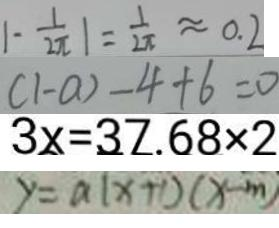<formula> <loc_0><loc_0><loc_500><loc_500>\vert - \frac { 1 } { 2 \pi } \vert = \frac { 1 } { 2 \pi } \approx 0 . 2 
 ( 1 - a ) - 4 + 6 = 0 
 3 x = 3 7 . 6 8 \times 2 
 y = a ( x + 1 ) ( x - m )</formula> 